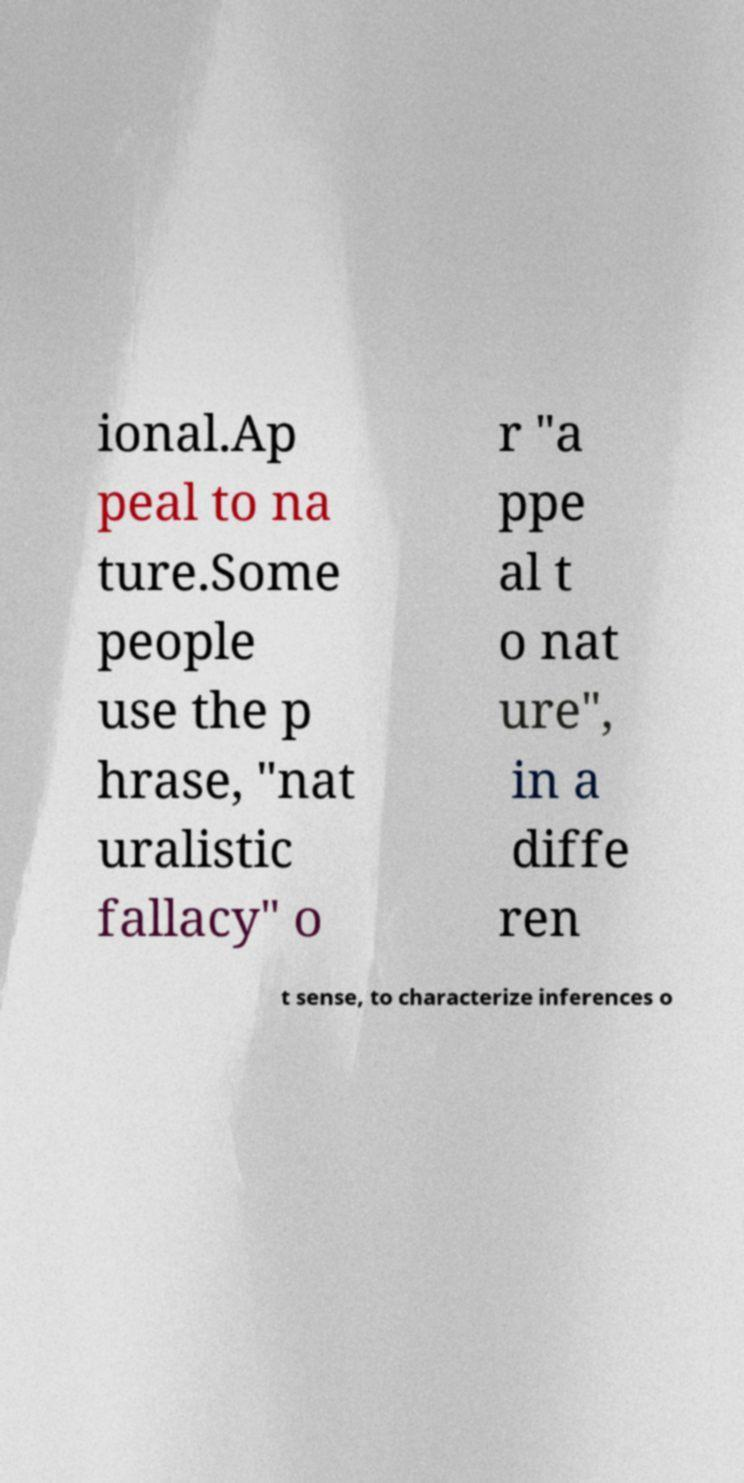Please identify and transcribe the text found in this image. ional.Ap peal to na ture.Some people use the p hrase, "nat uralistic fallacy" o r "a ppe al t o nat ure", in a diffe ren t sense, to characterize inferences o 